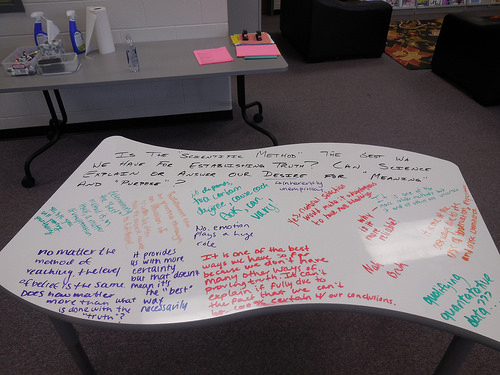<image>
Can you confirm if the messages is under the pink paper? No. The messages is not positioned under the pink paper. The vertical relationship between these objects is different. 